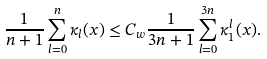<formula> <loc_0><loc_0><loc_500><loc_500>\frac { 1 } { n + 1 } \sum _ { l = 0 } ^ { n } \kappa _ { l } ( x ) \leq C _ { w } \frac { 1 } { 3 n + 1 } \sum _ { l = 0 } ^ { 3 n } \kappa _ { 1 } ^ { l } ( x ) .</formula> 